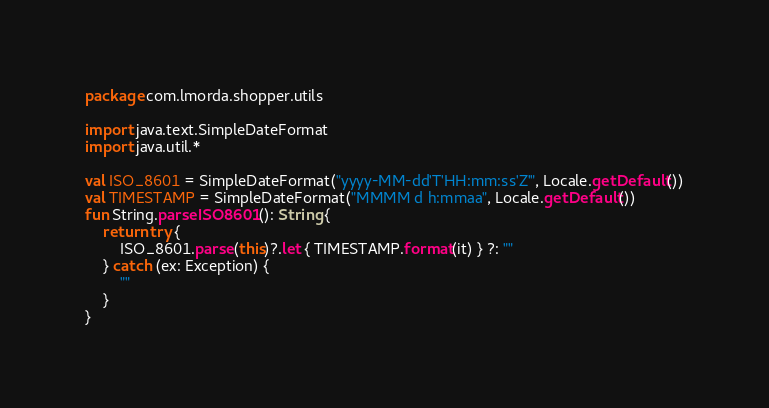Convert code to text. <code><loc_0><loc_0><loc_500><loc_500><_Kotlin_>package com.lmorda.shopper.utils

import java.text.SimpleDateFormat
import java.util.*

val ISO_8601 = SimpleDateFormat("yyyy-MM-dd'T'HH:mm:ss'Z'", Locale.getDefault())
val TIMESTAMP = SimpleDateFormat("MMMM d h:mmaa", Locale.getDefault())
fun String.parseISO8601(): String {
    return try {
        ISO_8601.parse(this)?.let { TIMESTAMP.format(it) } ?: ""
    } catch (ex: Exception) {
        ""
    }
}</code> 